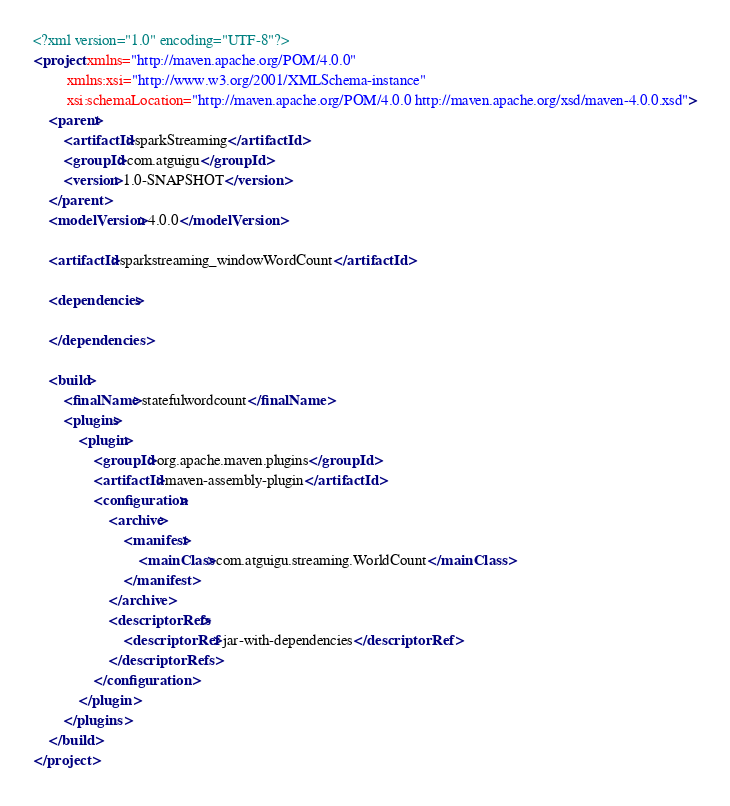<code> <loc_0><loc_0><loc_500><loc_500><_XML_><?xml version="1.0" encoding="UTF-8"?>
<project xmlns="http://maven.apache.org/POM/4.0.0"
         xmlns:xsi="http://www.w3.org/2001/XMLSchema-instance"
         xsi:schemaLocation="http://maven.apache.org/POM/4.0.0 http://maven.apache.org/xsd/maven-4.0.0.xsd">
    <parent>
        <artifactId>sparkStreaming</artifactId>
        <groupId>com.atguigu</groupId>
        <version>1.0-SNAPSHOT</version>
    </parent>
    <modelVersion>4.0.0</modelVersion>

    <artifactId>sparkstreaming_windowWordCount</artifactId>

    <dependencies>

    </dependencies>

    <build>
        <finalName>statefulwordcount</finalName>
        <plugins>
            <plugin>
                <groupId>org.apache.maven.plugins</groupId>
                <artifactId>maven-assembly-plugin</artifactId>
                <configuration>
                    <archive>
                        <manifest>
                            <mainClass>com.atguigu.streaming.WorldCount</mainClass>
                        </manifest>
                    </archive>
                    <descriptorRefs>
                        <descriptorRef>jar-with-dependencies</descriptorRef>
                    </descriptorRefs>
                </configuration>
            </plugin>
        </plugins>
    </build>
</project></code> 